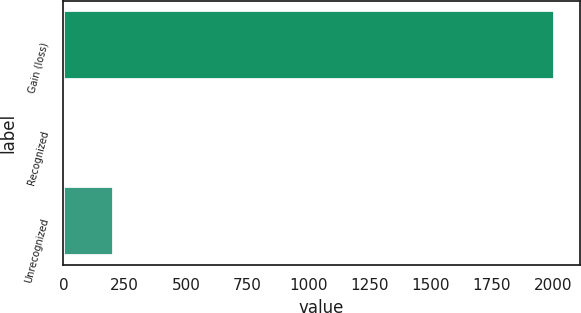Convert chart to OTSL. <chart><loc_0><loc_0><loc_500><loc_500><bar_chart><fcel>Gain (loss)<fcel>Recognized<fcel>Unrecognized<nl><fcel>2009<fcel>4<fcel>204.5<nl></chart> 